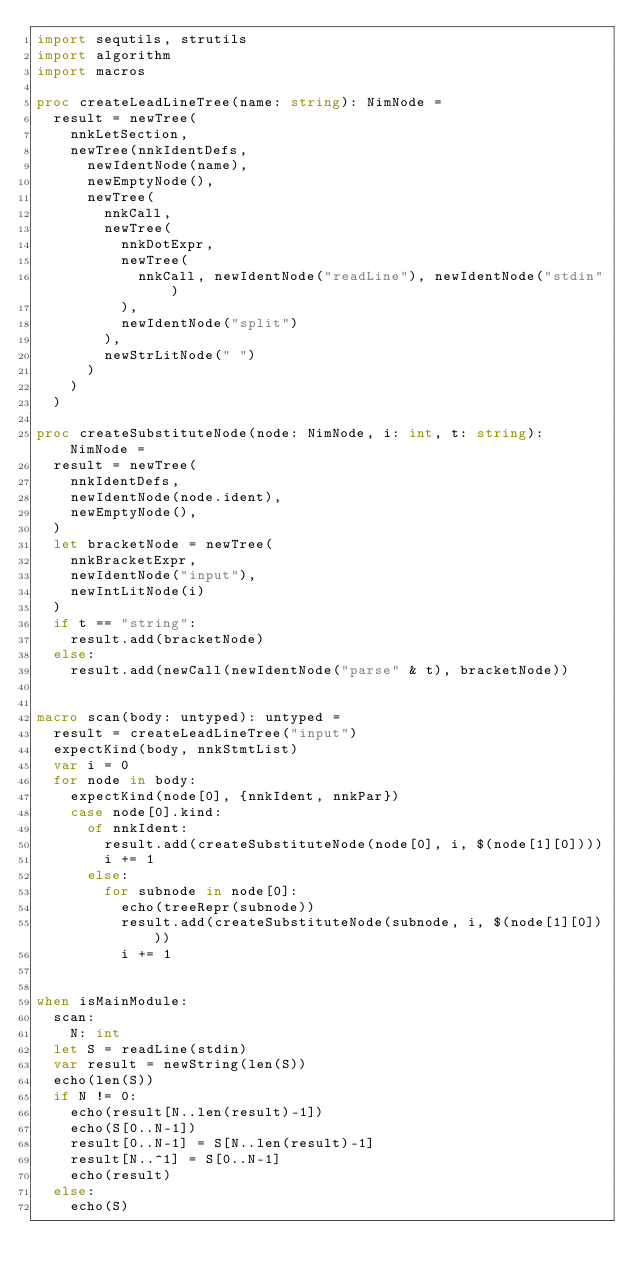Convert code to text. <code><loc_0><loc_0><loc_500><loc_500><_Nim_>import sequtils, strutils
import algorithm
import macros

proc createLeadLineTree(name: string): NimNode =
  result = newTree(
    nnkLetSection,
    newTree(nnkIdentDefs,
      newIdentNode(name),
      newEmptyNode(),
      newTree(
        nnkCall,
        newTree(
          nnkDotExpr,
          newTree(
            nnkCall, newIdentNode("readLine"), newIdentNode("stdin")
          ),
          newIdentNode("split")
        ),
        newStrLitNode(" ")
      )
    )
  )

proc createSubstituteNode(node: NimNode, i: int, t: string): NimNode =
  result = newTree(
    nnkIdentDefs, 
    newIdentNode(node.ident),
    newEmptyNode(),
  )
  let bracketNode = newTree(
    nnkBracketExpr,
    newIdentNode("input"),
    newIntLitNode(i)
  )
  if t == "string":
    result.add(bracketNode)
  else:
    result.add(newCall(newIdentNode("parse" & t), bracketNode))


macro scan(body: untyped): untyped =
  result = createLeadLineTree("input")
  expectKind(body, nnkStmtList)
  var i = 0
  for node in body:
    expectKind(node[0], {nnkIdent, nnkPar})
    case node[0].kind:
      of nnkIdent:
        result.add(createSubstituteNode(node[0], i, $(node[1][0])))
        i += 1
      else:
        for subnode in node[0]:
          echo(treeRepr(subnode))
          result.add(createSubstituteNode(subnode, i, $(node[1][0])))
          i += 1


when isMainModule:
  scan:
    N: int
  let S = readLine(stdin)
  var result = newString(len(S))
  echo(len(S))
  if N != 0:
    echo(result[N..len(result)-1])
    echo(S[0..N-1])
    result[0..N-1] = S[N..len(result)-1]
    result[N..^1] = S[0..N-1]
    echo(result)
  else:
    echo(S)</code> 